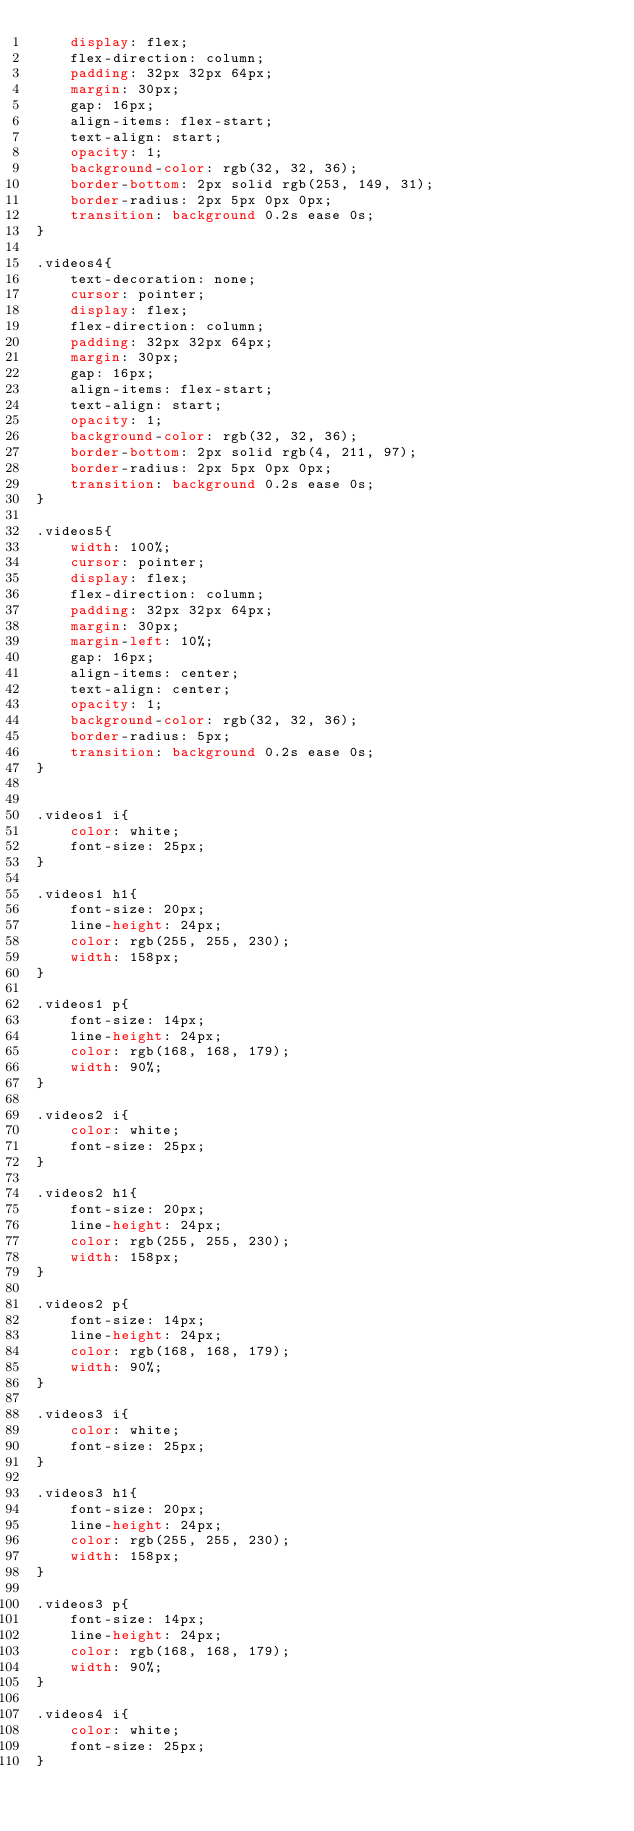Convert code to text. <code><loc_0><loc_0><loc_500><loc_500><_CSS_>    display: flex;
    flex-direction: column;
    padding: 32px 32px 64px;
    margin: 30px;
    gap: 16px;
    align-items: flex-start;
    text-align: start;
    opacity: 1;
    background-color: rgb(32, 32, 36);
    border-bottom: 2px solid rgb(253, 149, 31);
    border-radius: 2px 5px 0px 0px;
    transition: background 0.2s ease 0s;
}

.videos4{
    text-decoration: none;
    cursor: pointer;
    display: flex;
    flex-direction: column;
    padding: 32px 32px 64px;
    margin: 30px;
    gap: 16px;
    align-items: flex-start;
    text-align: start;
    opacity: 1;
    background-color: rgb(32, 32, 36);
    border-bottom: 2px solid rgb(4, 211, 97);
    border-radius: 2px 5px 0px 0px;
    transition: background 0.2s ease 0s;
}

.videos5{
    width: 100%;
    cursor: pointer;
    display: flex;
    flex-direction: column;
    padding: 32px 32px 64px;
    margin: 30px;
    margin-left: 10%;
    gap: 16px;
    align-items: center;
    text-align: center;
    opacity: 1;
    background-color: rgb(32, 32, 36);
    border-radius: 5px;
    transition: background 0.2s ease 0s;
}


.videos1 i{
    color: white;
    font-size: 25px;
}

.videos1 h1{
    font-size: 20px;
    line-height: 24px;
    color: rgb(255, 255, 230);
    width: 158px;
}

.videos1 p{
    font-size: 14px;
    line-height: 24px;
    color: rgb(168, 168, 179);
    width: 90%;
}

.videos2 i{
    color: white;
    font-size: 25px;
}

.videos2 h1{
    font-size: 20px;
    line-height: 24px;
    color: rgb(255, 255, 230);
    width: 158px;
}

.videos2 p{
    font-size: 14px;
    line-height: 24px;
    color: rgb(168, 168, 179);
    width: 90%;
}

.videos3 i{
    color: white;
    font-size: 25px;
}

.videos3 h1{
    font-size: 20px;
    line-height: 24px;
    color: rgb(255, 255, 230);
    width: 158px;
}

.videos3 p{
    font-size: 14px;
    line-height: 24px;
    color: rgb(168, 168, 179);
    width: 90%;
}

.videos4 i{
    color: white;
    font-size: 25px;
}
</code> 